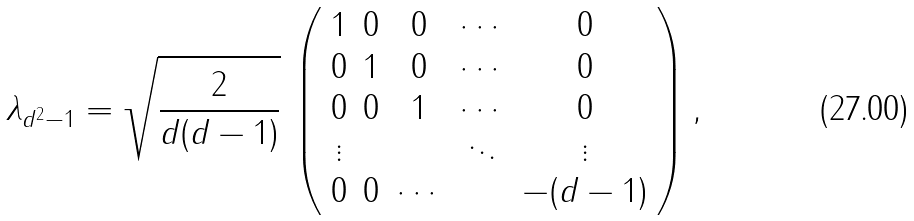Convert formula to latex. <formula><loc_0><loc_0><loc_500><loc_500>\lambda _ { d ^ { 2 } - 1 } = \sqrt { \frac { 2 } { d ( d - 1 ) } } \, \left ( \begin{array} { c c c c c } 1 & 0 & 0 & \cdots & 0 \\ 0 & 1 & 0 & \cdots & 0 \\ 0 & 0 & 1 & \cdots & 0 \\ \vdots & & & \ddots & \vdots \\ 0 & 0 & \cdots & & - ( d - 1 ) \end{array} \right ) ,</formula> 